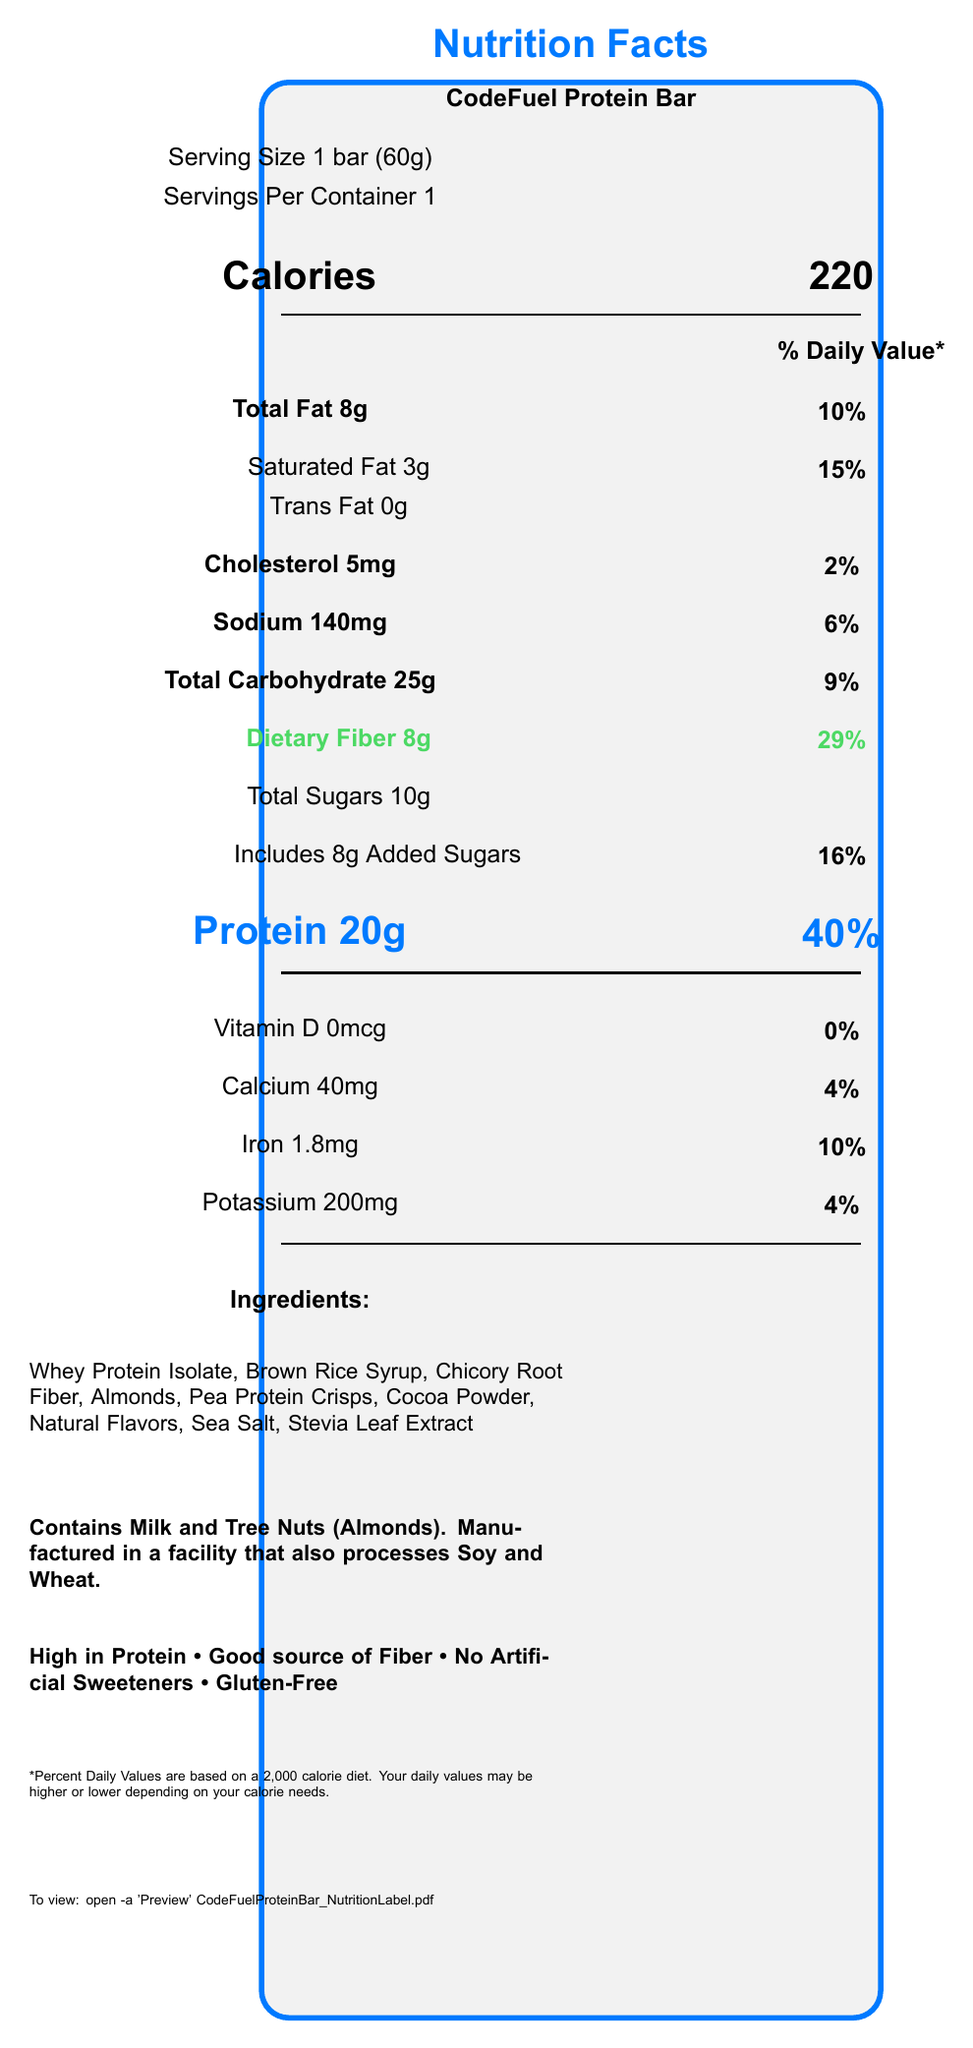what is the serving size of the CodeFuel Protein Bar? The serving size is directly mentioned as "Serving Size 1 bar (60g)" in the document.
Answer: 1 bar (60g) how many grams of protein are in one serving of the protein bar? The document explicitly states "Protein 20g" under the macronutrient section.
Answer: 20 grams what percentage of the daily value is the protein content for one serving? The protein content's daily value percentage is mentioned as "40%" next to "Protein 20g".
Answer: 40% how many grams of dietary fiber are in one serving of the protein bar? The document lists "Dietary Fiber 8g" under the macronutrients.
Answer: 8 grams what is the percentage daily value for dietary fiber in one serving? The daily value percentage for dietary fiber is listed as "29%" next to "Dietary Fiber 8g".
Answer: 29% which of the following is an ingredient in the CodeFuel Protein Bar? A. Whey Protein Isolate B. Corn Syrup C. Soy Protein Isolate D. Artificial Sweeteners Whey Protein Isolate is listed under "Ingredients" while the other options are not.
Answer: A how many calories are there per serving? The document states "Calories" followed by "220" in large font.
Answer: 220 calories is the CodeFuel Protein Bar free from artificial sweeteners? The "special features" section lists "No Artificial Sweeteners".
Answer: Yes summarize the main features of the CodeFuel Protein Bar. This summary encompasses the main points related to calories, protein, fiber, ingredients, and special features as detailed in the nutrition facts label.
Answer: The CodeFuel Protein Bar provides 220 calories per serving, high protein (20g, 40% daily value), and a good source of fiber (8g, 29% daily value). It is made with ingredients such as Whey Protein Isolate, contains no artificial sweeteners, and is gluten-free. Additional features include its allergen information, describing that it contains milk and tree nuts and that it is manufactured in a facility that processes soy and wheat. how much sodium is in one serving of the protein bar? The document lists "Sodium 140mg" along with its daily value percentage.
Answer: 140 mg what are the main allergens found in the CodeFuel Protein Bar? A. Soy and Wheat B. Milk and Tree Nuts C. Peanuts and Eggs D. Gluten and Soy According to the allergen information, the bar contains "Milk and Tree Nuts (Almonds)".
Answer: B is the protein bar gluten-free? The "special features" section explicitly lists "Gluten-Free".
Answer: Yes can you determine how much Vitamin C is in the protein bar? The document does not mention Vitamin C, so its quantity cannot be determined.
Answer: Not enough information how many grams of total carbohydrates does one serving contain? The document states "Total Carbohydrate 25g" under the macronutrients.
Answer: 25 grams which macronutrient has the highest daily value percentage? A. Total Fat B. Dietary Fiber C. Protein D. Sodium Protein has the highest daily value percentage at 40% compared to the others listed.
Answer: C 